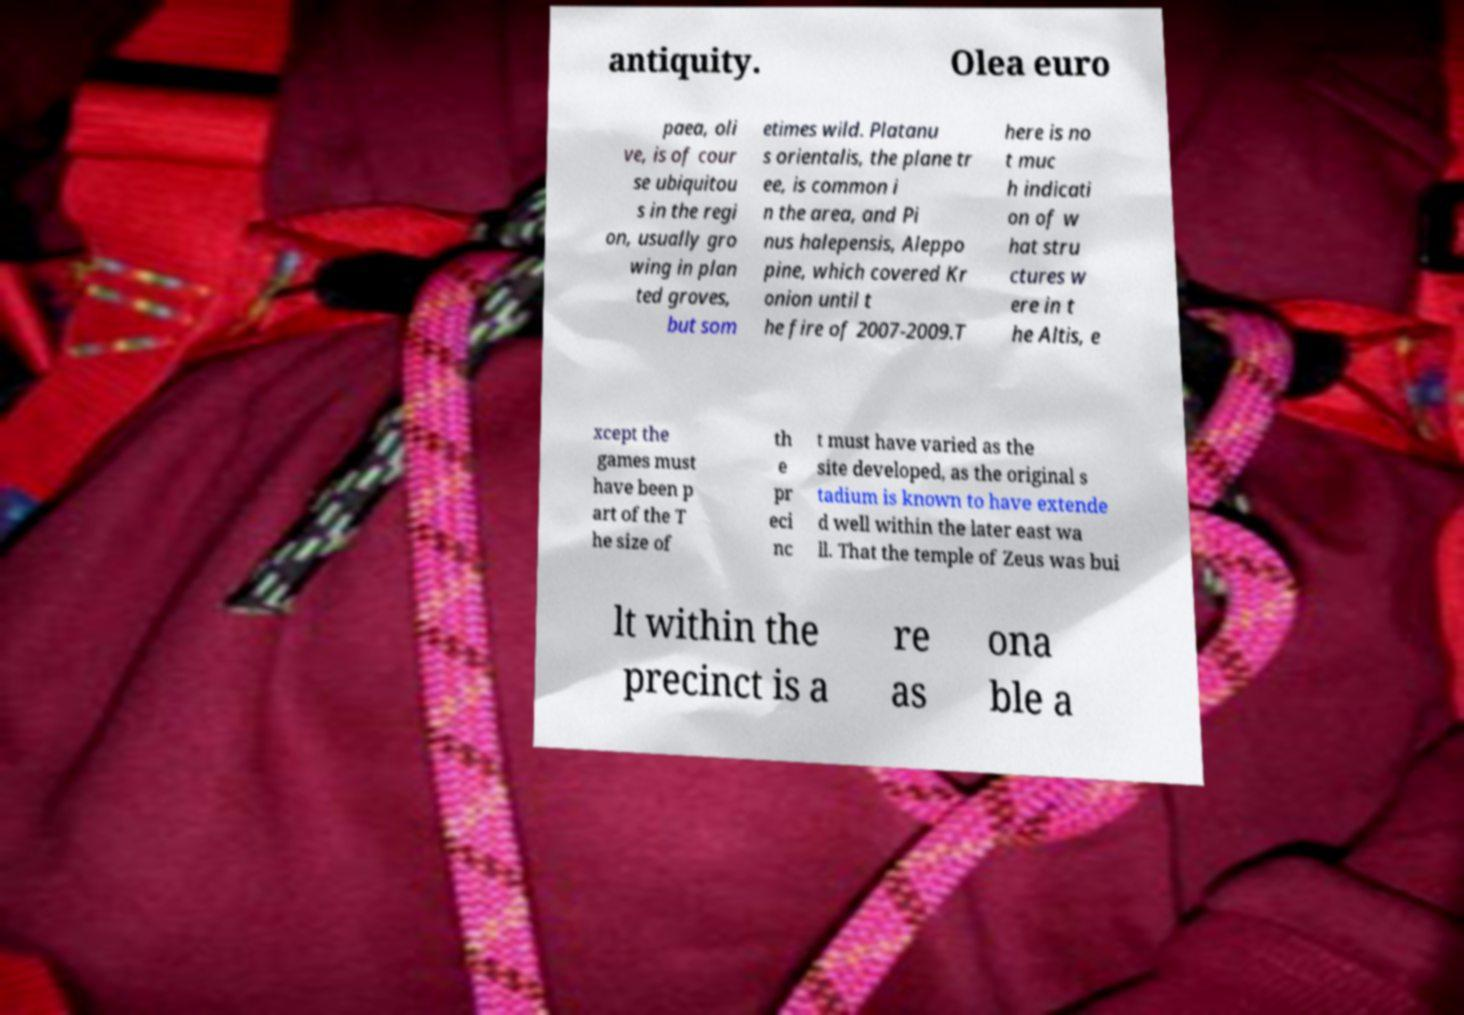For documentation purposes, I need the text within this image transcribed. Could you provide that? antiquity. Olea euro paea, oli ve, is of cour se ubiquitou s in the regi on, usually gro wing in plan ted groves, but som etimes wild. Platanu s orientalis, the plane tr ee, is common i n the area, and Pi nus halepensis, Aleppo pine, which covered Kr onion until t he fire of 2007-2009.T here is no t muc h indicati on of w hat stru ctures w ere in t he Altis, e xcept the games must have been p art of the T he size of th e pr eci nc t must have varied as the site developed, as the original s tadium is known to have extende d well within the later east wa ll. That the temple of Zeus was bui lt within the precinct is a re as ona ble a 